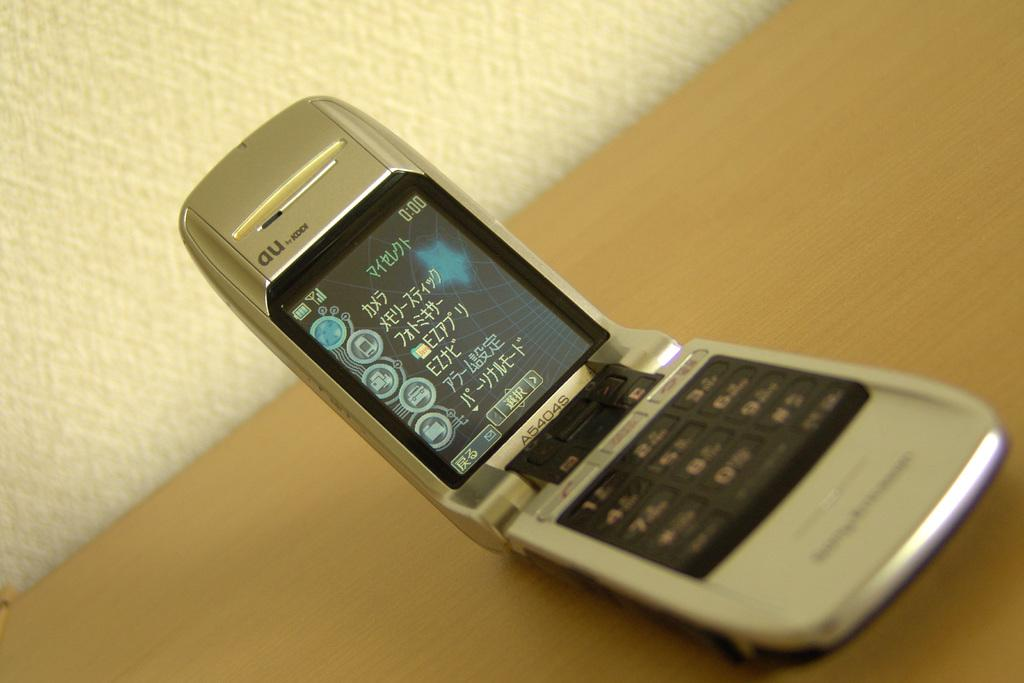<image>
Present a compact description of the photo's key features. a phone with au on the top of it 